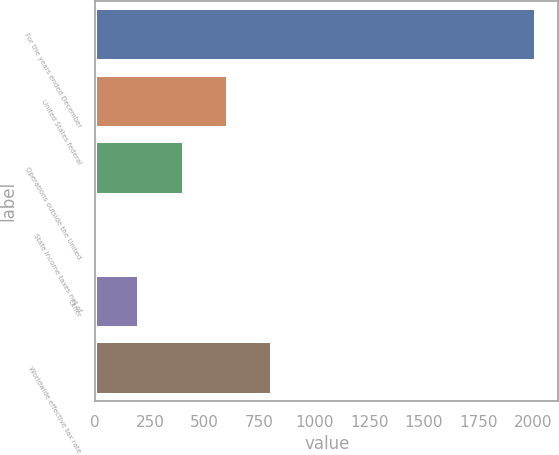Convert chart. <chart><loc_0><loc_0><loc_500><loc_500><bar_chart><fcel>For the years ended December<fcel>United States federal<fcel>Operations outside the United<fcel>State income taxes net of<fcel>Other<fcel>Worldwide effective tax rate<nl><fcel>2013<fcel>604.6<fcel>403.4<fcel>1<fcel>202.2<fcel>805.8<nl></chart> 